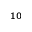Convert formula to latex. <formula><loc_0><loc_0><loc_500><loc_500>^ { 1 0 }</formula> 